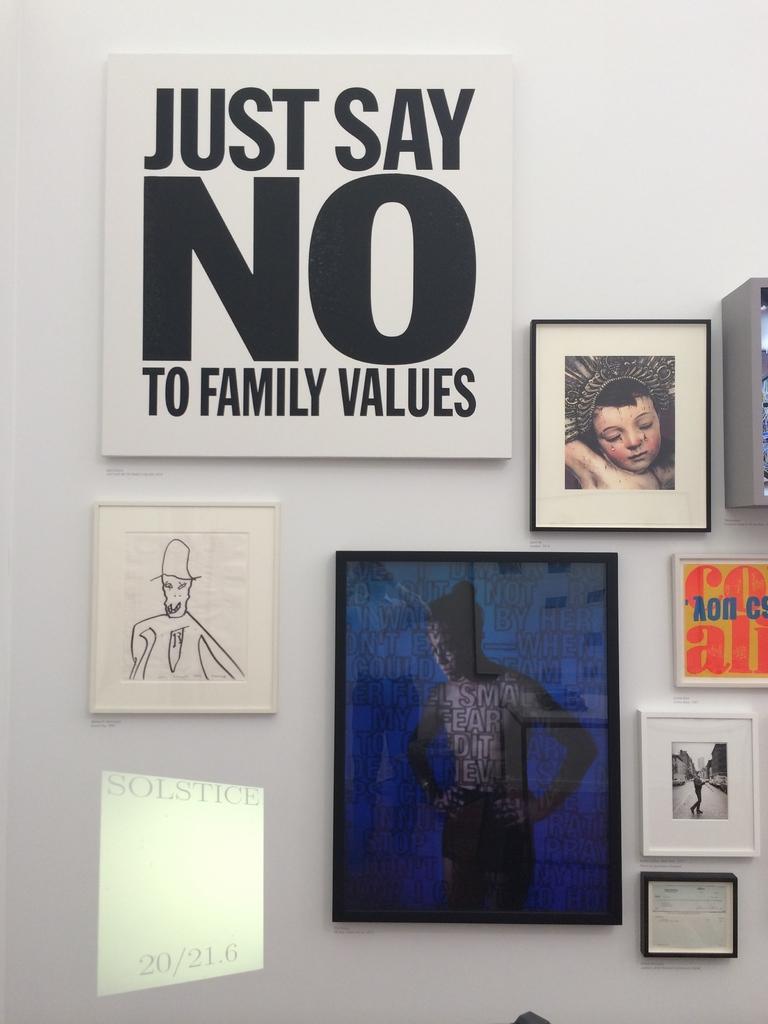In one or two sentences, can you explain what this image depicts? In the picture there is a wall, on the wall there are many frames present, there is some text present. 